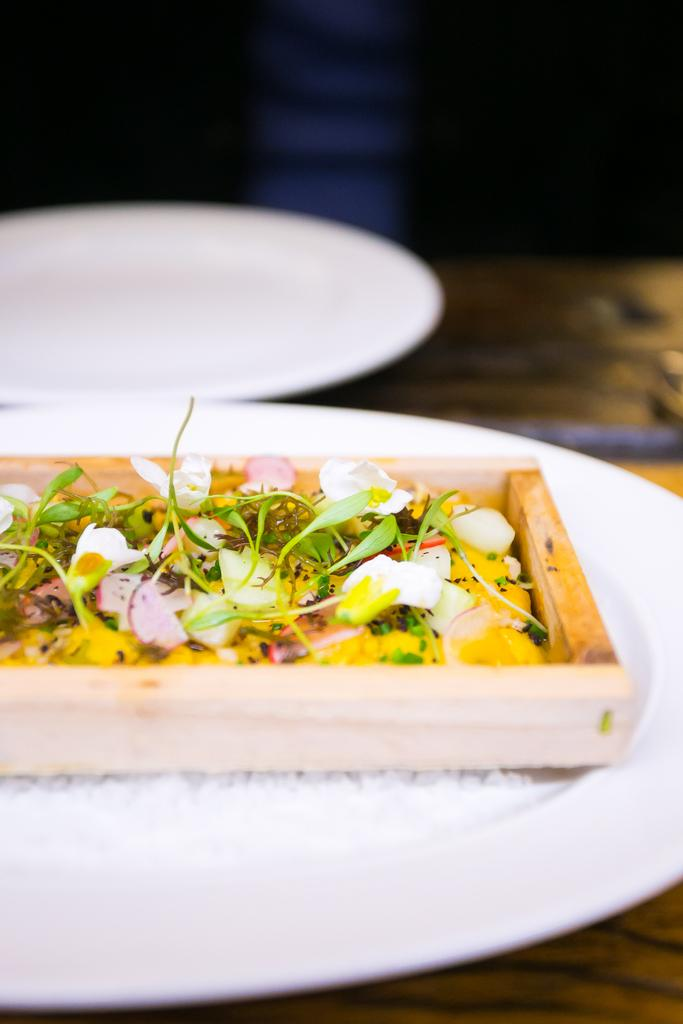What type of plate is visible in the image? There is a wooden plate and a white color plate in the image. What is on the wooden plate? There are food ingredients on the wooden plate. What is on the white color plate? There are food ingredients on the white color plate. Can you describe the position of the other plate in the image? There is another plate at the top of the image. What type of machine is visible in the image? There is no machine present in the image. What is the time of day depicted in the image? The time of day is not mentioned or depicted in the image. 